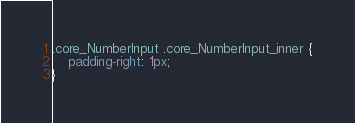Convert code to text. <code><loc_0><loc_0><loc_500><loc_500><_CSS_>.core_NumberInput .core_NumberInput_inner {
    padding-right: 1px;
}</code> 